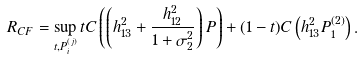<formula> <loc_0><loc_0><loc_500><loc_500>R _ { C F } = \sup _ { t , P _ { i } ^ { ( j ) } } t C \left ( \left ( h _ { 1 3 } ^ { 2 } + \frac { h _ { 1 2 } ^ { 2 } } { 1 + \sigma _ { 2 } ^ { 2 } } \right ) P \right ) + ( 1 - t ) C \left ( h _ { 1 3 } ^ { 2 } P _ { 1 } ^ { ( 2 ) } \right ) .</formula> 